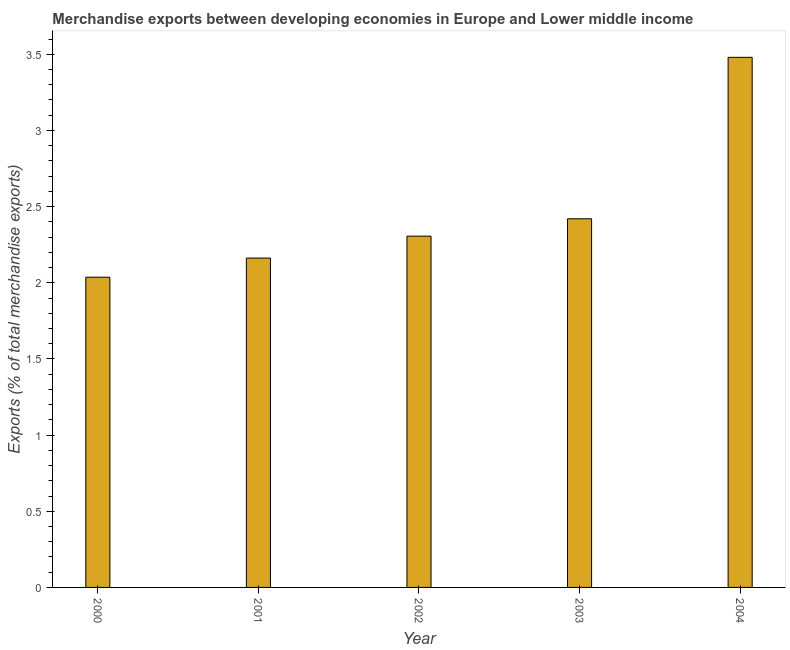Does the graph contain any zero values?
Keep it short and to the point. No. Does the graph contain grids?
Keep it short and to the point. No. What is the title of the graph?
Provide a succinct answer. Merchandise exports between developing economies in Europe and Lower middle income. What is the label or title of the Y-axis?
Provide a short and direct response. Exports (% of total merchandise exports). What is the merchandise exports in 2000?
Make the answer very short. 2.04. Across all years, what is the maximum merchandise exports?
Your answer should be compact. 3.48. Across all years, what is the minimum merchandise exports?
Your answer should be very brief. 2.04. In which year was the merchandise exports minimum?
Keep it short and to the point. 2000. What is the sum of the merchandise exports?
Your answer should be very brief. 12.41. What is the difference between the merchandise exports in 2002 and 2004?
Provide a short and direct response. -1.17. What is the average merchandise exports per year?
Provide a short and direct response. 2.48. What is the median merchandise exports?
Make the answer very short. 2.31. What is the ratio of the merchandise exports in 2001 to that in 2004?
Offer a terse response. 0.62. Is the merchandise exports in 2003 less than that in 2004?
Give a very brief answer. Yes. Is the difference between the merchandise exports in 2000 and 2003 greater than the difference between any two years?
Give a very brief answer. No. What is the difference between the highest and the second highest merchandise exports?
Your response must be concise. 1.06. Is the sum of the merchandise exports in 2003 and 2004 greater than the maximum merchandise exports across all years?
Provide a short and direct response. Yes. What is the difference between the highest and the lowest merchandise exports?
Keep it short and to the point. 1.44. How many bars are there?
Your answer should be very brief. 5. What is the difference between two consecutive major ticks on the Y-axis?
Provide a succinct answer. 0.5. What is the Exports (% of total merchandise exports) in 2000?
Offer a very short reply. 2.04. What is the Exports (% of total merchandise exports) of 2001?
Provide a succinct answer. 2.16. What is the Exports (% of total merchandise exports) in 2002?
Give a very brief answer. 2.31. What is the Exports (% of total merchandise exports) of 2003?
Ensure brevity in your answer.  2.42. What is the Exports (% of total merchandise exports) in 2004?
Provide a succinct answer. 3.48. What is the difference between the Exports (% of total merchandise exports) in 2000 and 2001?
Offer a very short reply. -0.13. What is the difference between the Exports (% of total merchandise exports) in 2000 and 2002?
Offer a terse response. -0.27. What is the difference between the Exports (% of total merchandise exports) in 2000 and 2003?
Ensure brevity in your answer.  -0.38. What is the difference between the Exports (% of total merchandise exports) in 2000 and 2004?
Your answer should be very brief. -1.44. What is the difference between the Exports (% of total merchandise exports) in 2001 and 2002?
Give a very brief answer. -0.14. What is the difference between the Exports (% of total merchandise exports) in 2001 and 2003?
Your answer should be very brief. -0.26. What is the difference between the Exports (% of total merchandise exports) in 2001 and 2004?
Provide a short and direct response. -1.32. What is the difference between the Exports (% of total merchandise exports) in 2002 and 2003?
Provide a succinct answer. -0.11. What is the difference between the Exports (% of total merchandise exports) in 2002 and 2004?
Your answer should be compact. -1.17. What is the difference between the Exports (% of total merchandise exports) in 2003 and 2004?
Your answer should be compact. -1.06. What is the ratio of the Exports (% of total merchandise exports) in 2000 to that in 2001?
Your answer should be compact. 0.94. What is the ratio of the Exports (% of total merchandise exports) in 2000 to that in 2002?
Give a very brief answer. 0.88. What is the ratio of the Exports (% of total merchandise exports) in 2000 to that in 2003?
Give a very brief answer. 0.84. What is the ratio of the Exports (% of total merchandise exports) in 2000 to that in 2004?
Offer a terse response. 0.58. What is the ratio of the Exports (% of total merchandise exports) in 2001 to that in 2002?
Give a very brief answer. 0.94. What is the ratio of the Exports (% of total merchandise exports) in 2001 to that in 2003?
Provide a short and direct response. 0.89. What is the ratio of the Exports (% of total merchandise exports) in 2001 to that in 2004?
Give a very brief answer. 0.62. What is the ratio of the Exports (% of total merchandise exports) in 2002 to that in 2003?
Offer a terse response. 0.95. What is the ratio of the Exports (% of total merchandise exports) in 2002 to that in 2004?
Make the answer very short. 0.66. What is the ratio of the Exports (% of total merchandise exports) in 2003 to that in 2004?
Give a very brief answer. 0.69. 